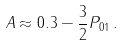Convert formula to latex. <formula><loc_0><loc_0><loc_500><loc_500>A \approx 0 . 3 - \frac { 3 } { 2 } P _ { 0 1 } \, .</formula> 